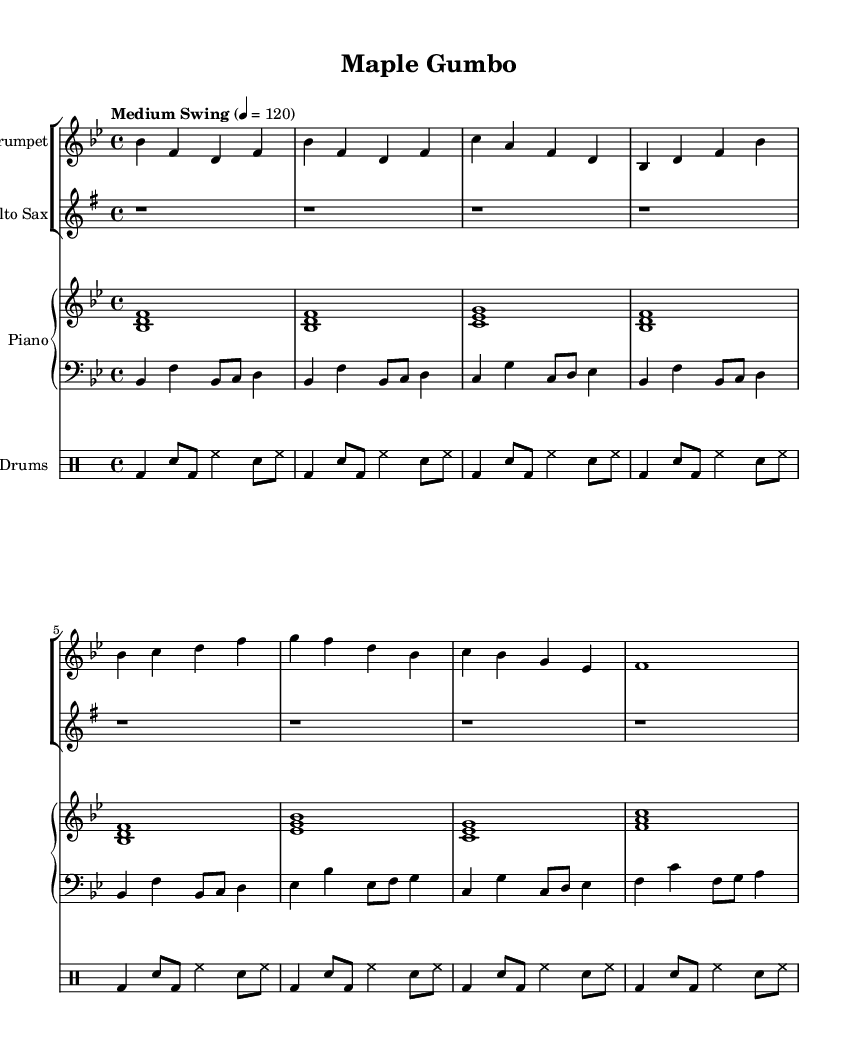What is the key signature of this music? The key signature is indicated by the placement of the sharp or flat symbols at the beginning of the staff. In this piece, there are two flats (B flat and E flat), indicating that the key is B flat major.
Answer: B flat major What is the time signature of this music? The time signature is shown at the beginning of the piece, represented by the numbers stacked in a fraction-like manner. Here, it is 4 over 4, meaning there are four beats per measure.
Answer: 4/4 What is the tempo marking for this piece? The tempo marking is located above the staff, indicating the speed of the music. This piece has "Medium Swing" as its tempo marking, indicating a style and pace typical for swing jazz.
Answer: Medium Swing How many measures are in the A section of this piece? The A section is identified as the portion of the piece that follows the intro. Counting the measures indicated in the A section, there are 6 measures in total.
Answer: 6 What intervals are used in the trumpet's intro section? By analyzing the notes in the trumpet's intro section, we find various intervals such as fourths and thirds. Looking specifically, the interval between the notes B flat and F is a fourth. Additionally, other intervals can be identified, focusing on intervals created by the movement in the melodic line.
Answer: Fourths and thirds What is the style of the piano accompaniment? The piano part features characteristic jazz chords and rhythmic phrasing typical of a jazz piano style. The usage of chords with stacked notes showcases a comping style common in jazz settings.
Answer: Jazz comping style Which instrument has an empty intro section? The alto saxophone part starts with four measures of rests (indicated by 'r1'), showing that it has no notes during the intro section, contrasting with the other instruments that play.
Answer: Alto Saxophone 